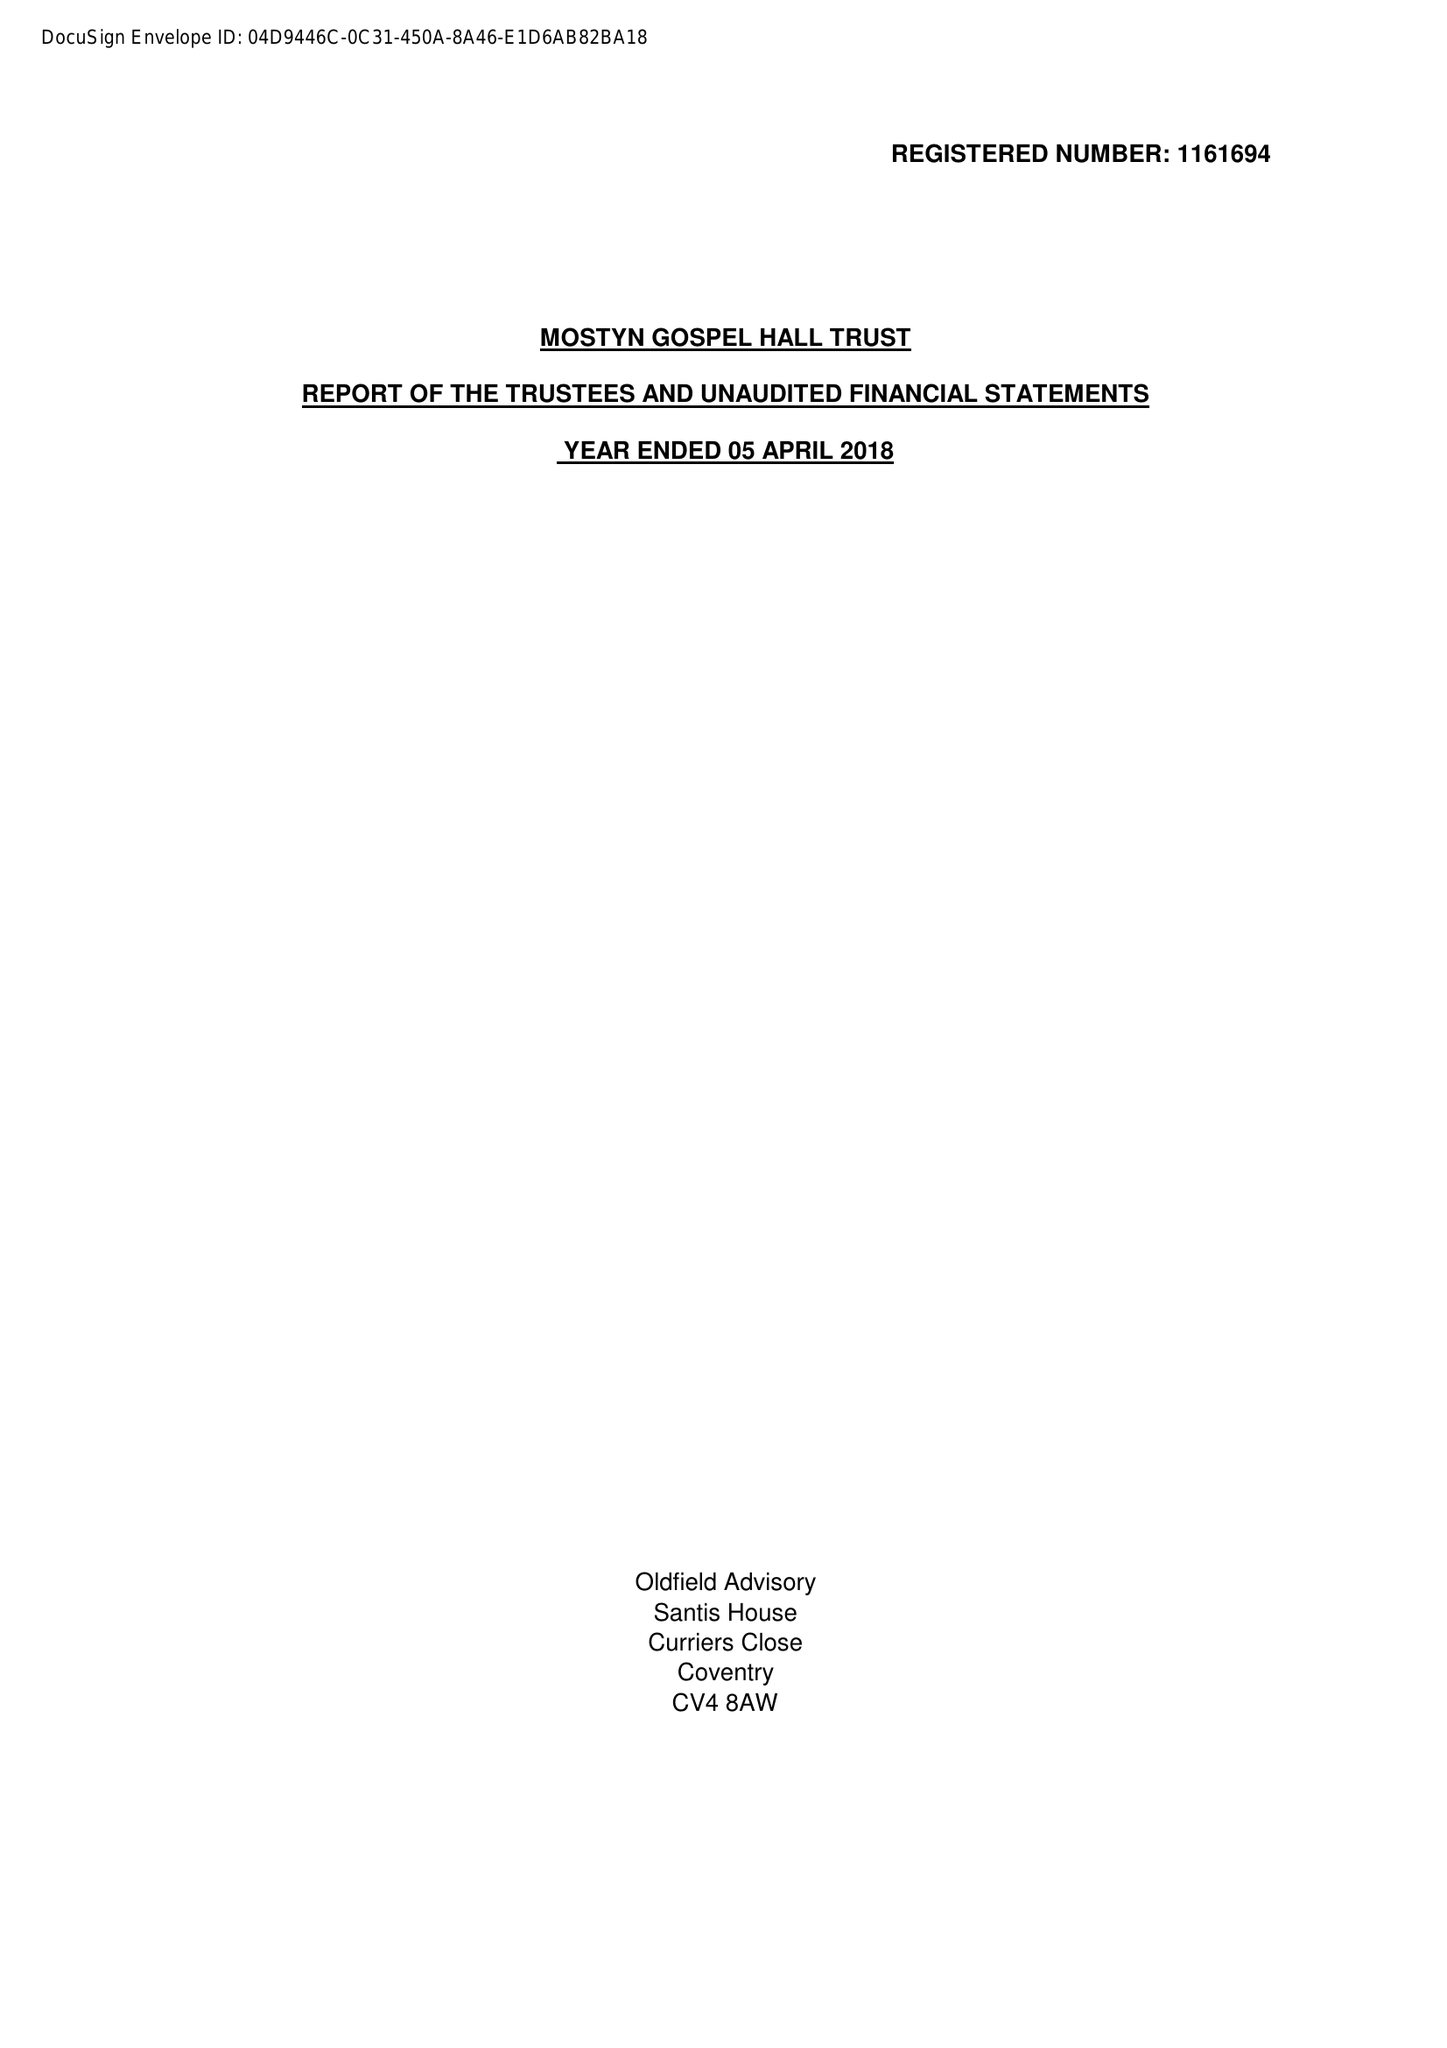What is the value for the address__street_line?
Answer the question using a single word or phrase. 190 STATION ROAD 